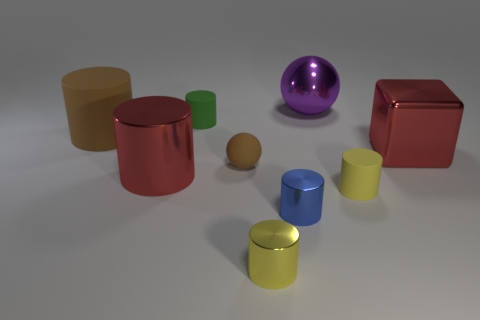What is the material of the thing that is the same color as the large metallic block?
Your answer should be very brief. Metal. What number of other objects are there of the same color as the big block?
Keep it short and to the point. 1. What color is the other large object that is the same shape as the large matte thing?
Offer a very short reply. Red. What color is the tiny rubber cylinder that is in front of the large red thing to the right of the sphere that is in front of the green thing?
Keep it short and to the point. Yellow. Does the purple thing have the same shape as the rubber thing behind the big brown cylinder?
Ensure brevity in your answer.  No. There is a shiny thing that is both behind the blue metallic cylinder and in front of the block; what is its color?
Your response must be concise. Red. Is there a large red matte thing that has the same shape as the big brown matte object?
Provide a succinct answer. No. Do the rubber sphere and the big matte cylinder have the same color?
Ensure brevity in your answer.  Yes. Is there a blue cylinder behind the big red shiny thing on the right side of the blue metal thing?
Ensure brevity in your answer.  No. What number of objects are small cylinders that are in front of the big rubber cylinder or large red things right of the yellow metal cylinder?
Offer a terse response. 4. 